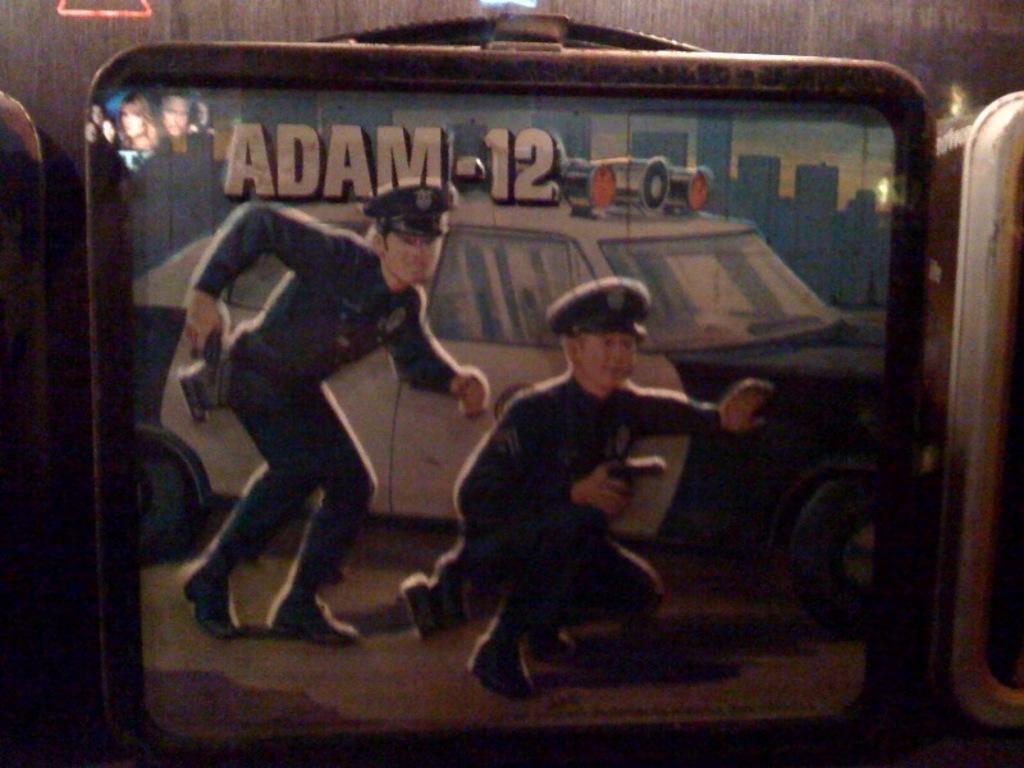How would you summarize this image in a sentence or two? In this picture I can see the poster which is placed on the wall. In the poster I can see the car and two police officers. Behind the car I can see many buildings. 